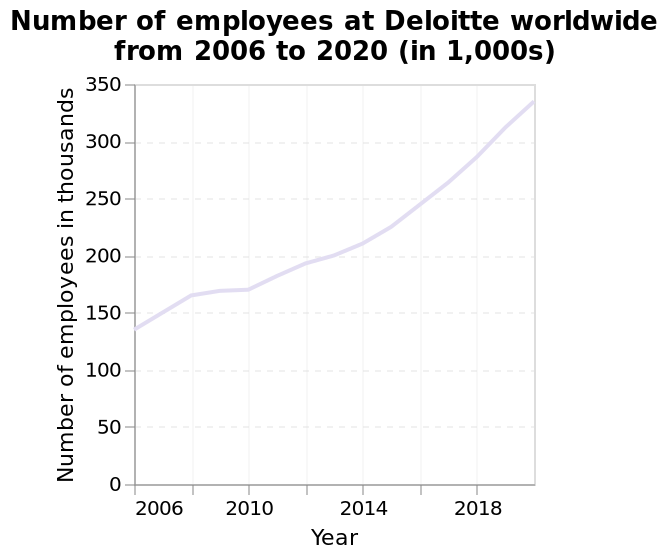<image>
Has the number of employees increased or decreased from 2006 to 2020?  The number of employees has significantly increased from 2006 to 2020. What is the y-axis labeled in the line graph? The y-axis is labeled "Number of employees in thousands". Did the number of employees remain the same from 2006 to 2020?  No, the number of employees has significantly increased from 2006 to 2020. What is the label of the x-axis? The x-axis is labeled "Year". 